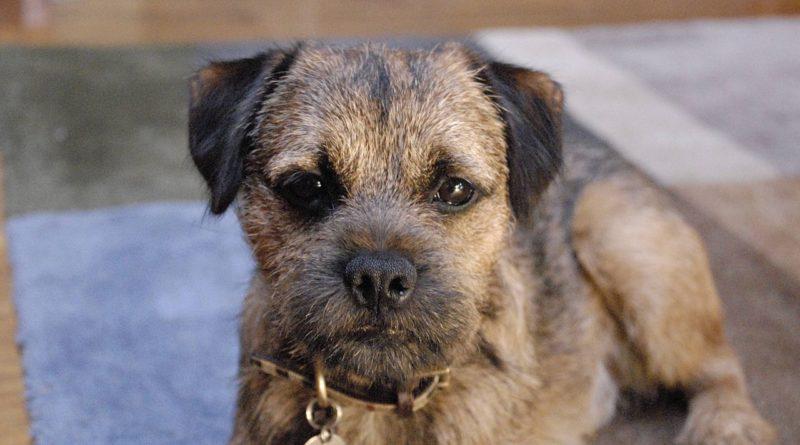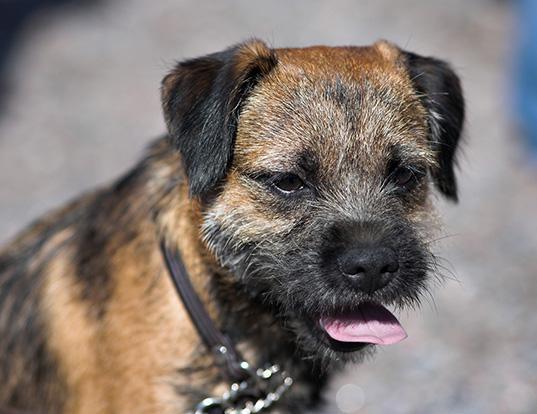The first image is the image on the left, the second image is the image on the right. Considering the images on both sides, is "There are purple flowers behind the dog in one of the images but not the other." valid? Answer yes or no. No. The first image is the image on the left, the second image is the image on the right. Given the left and right images, does the statement "The collar on the dog in the right image, it is clearly visible." hold true? Answer yes or no. Yes. 